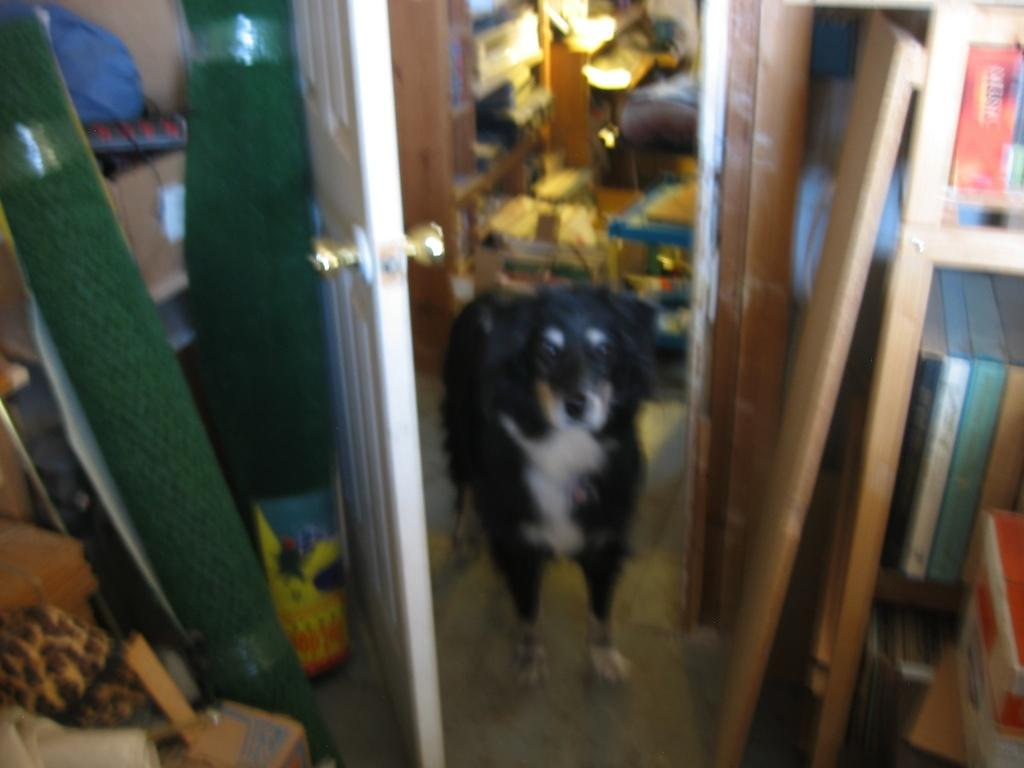What type of animal is present in the image? There is a dog in the image. What structure can be seen in the image? There is a door in the image. What color and type of flooring is on the left side of the image? There are green color mats on the left side of the image. What type of health advice is the dog giving in the image? The image does not depict the dog giving any health advice. 